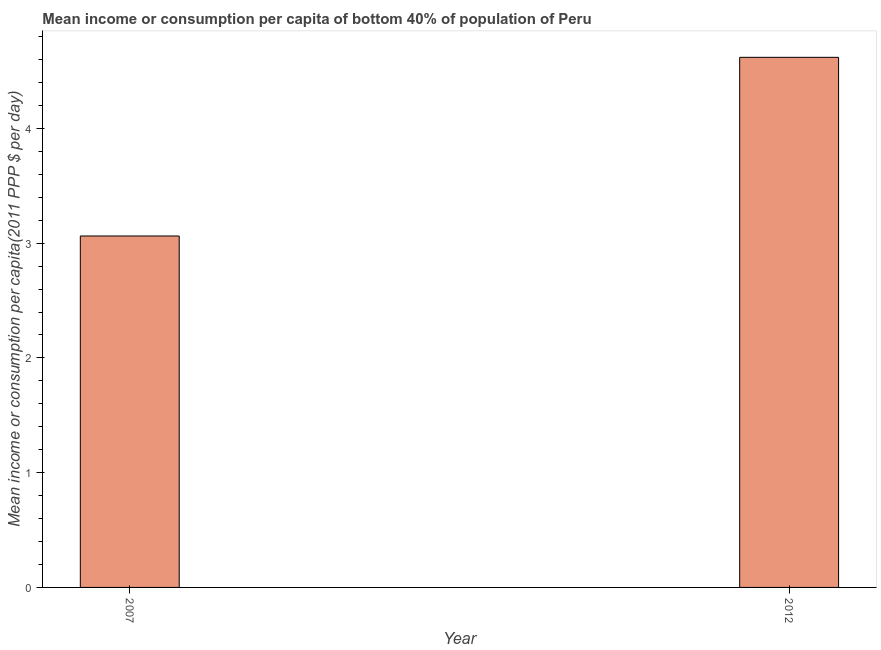Does the graph contain grids?
Your response must be concise. No. What is the title of the graph?
Keep it short and to the point. Mean income or consumption per capita of bottom 40% of population of Peru. What is the label or title of the X-axis?
Keep it short and to the point. Year. What is the label or title of the Y-axis?
Give a very brief answer. Mean income or consumption per capita(2011 PPP $ per day). What is the mean income or consumption in 2007?
Provide a short and direct response. 3.06. Across all years, what is the maximum mean income or consumption?
Your response must be concise. 4.62. Across all years, what is the minimum mean income or consumption?
Give a very brief answer. 3.06. In which year was the mean income or consumption maximum?
Give a very brief answer. 2012. In which year was the mean income or consumption minimum?
Your response must be concise. 2007. What is the sum of the mean income or consumption?
Provide a succinct answer. 7.68. What is the difference between the mean income or consumption in 2007 and 2012?
Give a very brief answer. -1.56. What is the average mean income or consumption per year?
Offer a terse response. 3.84. What is the median mean income or consumption?
Your answer should be very brief. 3.84. Do a majority of the years between 2007 and 2012 (inclusive) have mean income or consumption greater than 3.4 $?
Offer a very short reply. No. What is the ratio of the mean income or consumption in 2007 to that in 2012?
Your response must be concise. 0.66. In how many years, is the mean income or consumption greater than the average mean income or consumption taken over all years?
Ensure brevity in your answer.  1. How many bars are there?
Your answer should be very brief. 2. Are all the bars in the graph horizontal?
Make the answer very short. No. How many years are there in the graph?
Provide a short and direct response. 2. Are the values on the major ticks of Y-axis written in scientific E-notation?
Provide a short and direct response. No. What is the Mean income or consumption per capita(2011 PPP $ per day) of 2007?
Your answer should be very brief. 3.06. What is the Mean income or consumption per capita(2011 PPP $ per day) in 2012?
Your answer should be compact. 4.62. What is the difference between the Mean income or consumption per capita(2011 PPP $ per day) in 2007 and 2012?
Give a very brief answer. -1.56. What is the ratio of the Mean income or consumption per capita(2011 PPP $ per day) in 2007 to that in 2012?
Offer a very short reply. 0.66. 